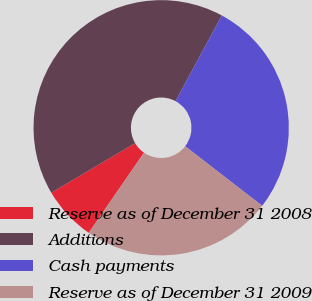<chart> <loc_0><loc_0><loc_500><loc_500><pie_chart><fcel>Reserve as of December 31 2008<fcel>Additions<fcel>Cash payments<fcel>Reserve as of December 31 2009<nl><fcel>6.9%<fcel>41.38%<fcel>27.59%<fcel>24.14%<nl></chart> 